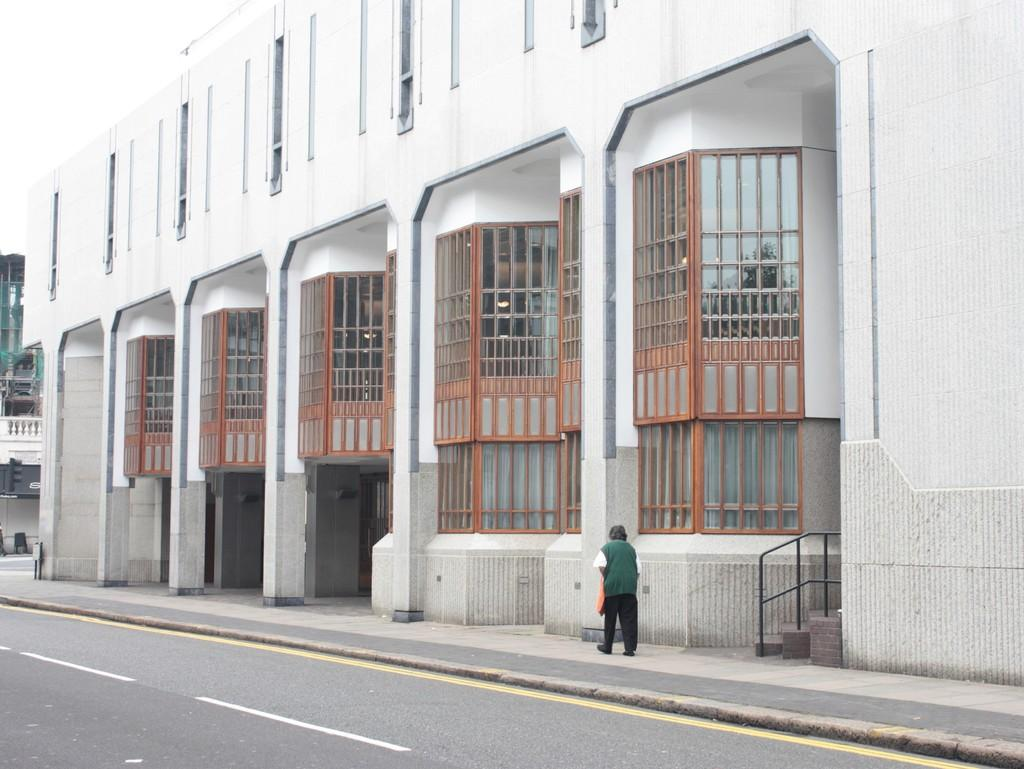What is the main structure in the image? There is a building in the image. Can you describe the color of the building? The building is white. Is there anyone near the building? Yes, there is a person standing beside the building. What else can be seen in the background of the image? There is another building in the background of the image. Can you see the person attempting to fly a scarf in the image? There is no person attempting to fly a scarf in the image. 